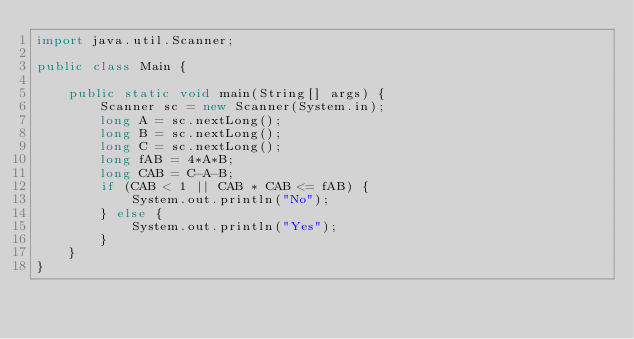<code> <loc_0><loc_0><loc_500><loc_500><_Java_>import java.util.Scanner;

public class Main {
    
    public static void main(String[] args) {
        Scanner sc = new Scanner(System.in);
        long A = sc.nextLong();
        long B = sc.nextLong();
        long C = sc.nextLong();
        long fAB = 4*A*B;
        long CAB = C-A-B;
        if (CAB < 1 || CAB * CAB <= fAB) {
            System.out.println("No");
        } else {
            System.out.println("Yes");
        }
    }
}</code> 